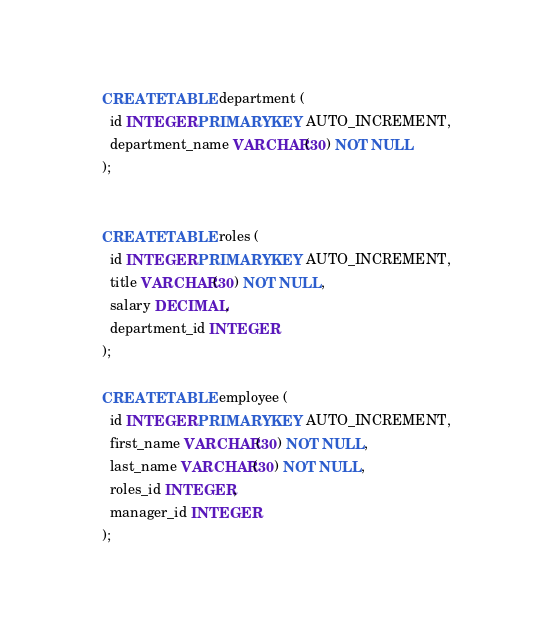Convert code to text. <code><loc_0><loc_0><loc_500><loc_500><_SQL_>


CREATE TABLE department (
  id INTEGER PRIMARY KEY AUTO_INCREMENT,
  department_name VARCHAR(30) NOT NULL
);


CREATE TABLE roles (
  id INTEGER PRIMARY KEY AUTO_INCREMENT,
  title VARCHAR(30) NOT NULL,
  salary DECIMAL,
  department_id INTEGER
);

CREATE TABLE employee (
  id INTEGER PRIMARY KEY AUTO_INCREMENT,
  first_name VARCHAR(30) NOT NULL,
  last_name VARCHAR(30) NOT NULL,
  roles_id INTEGER,
  manager_id INTEGER
);




</code> 